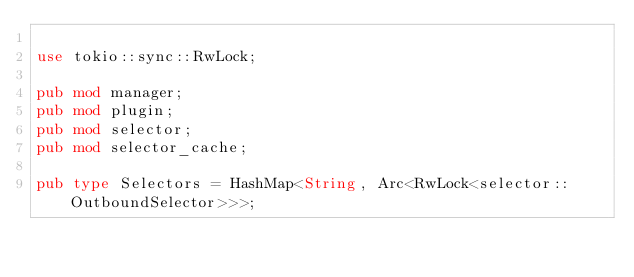Convert code to text. <code><loc_0><loc_0><loc_500><loc_500><_Rust_>
use tokio::sync::RwLock;

pub mod manager;
pub mod plugin;
pub mod selector;
pub mod selector_cache;

pub type Selectors = HashMap<String, Arc<RwLock<selector::OutboundSelector>>>;
</code> 